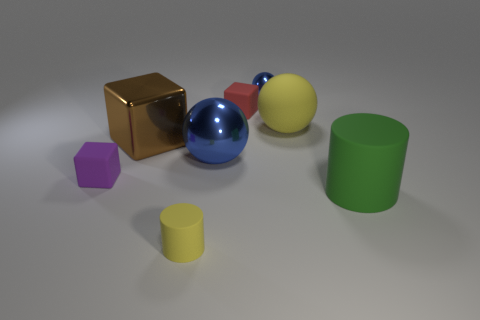Subtract all purple matte cubes. How many cubes are left? 2 Subtract 1 cubes. How many cubes are left? 2 Subtract all yellow cylinders. How many blue spheres are left? 2 Add 1 purple blocks. How many objects exist? 9 Subtract all gray balls. Subtract all brown cylinders. How many balls are left? 3 Subtract all balls. How many objects are left? 5 Subtract all brown rubber blocks. Subtract all matte things. How many objects are left? 3 Add 1 yellow balls. How many yellow balls are left? 2 Add 3 blue matte balls. How many blue matte balls exist? 3 Subtract 0 cyan balls. How many objects are left? 8 